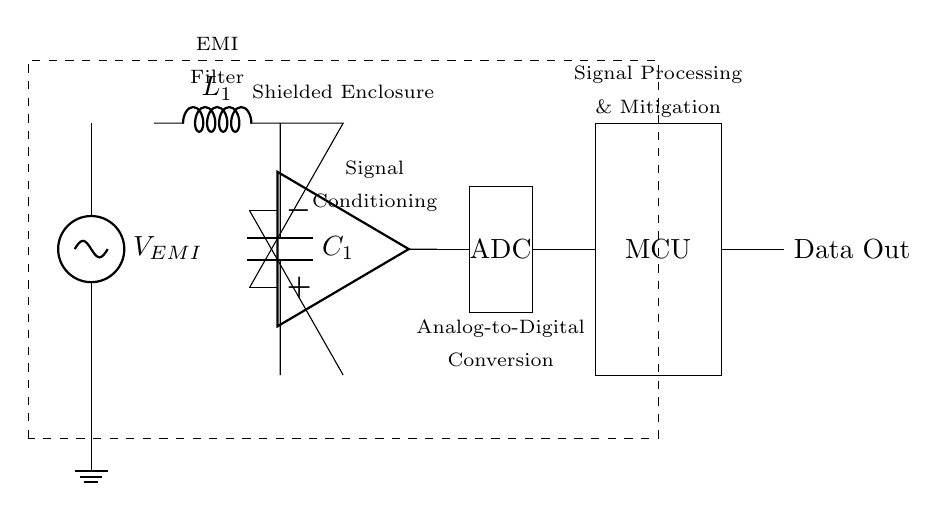What type of component is connected to the voltage source? The voltage source is connected to an inductor as part of the EMI filter, which is depicted just after the voltage source.
Answer: Inductor What does the dashed rectangle represent in this circuit? The dashed rectangle represents a shielded enclosure, which provides physical protection against electromagnetic interference.
Answer: Shielded Enclosure How many components are in the signal conditioning section? The signal conditioning section consists of one op-amp and additional connections, so there is a total of one component (the op-amp) explicitly shown.
Answer: One What is the function of the ADC in this circuit? The ADC converts the analog signals processed by the signal conditioning section into digital signals for the microcontroller to process.
Answer: Analog-to-Digital Conversion What type of circuit is primarily represented in this diagram? This diagram represents an EMI detection and mitigation circuit aimed at protecting sensitive data transmission through filtering and signal processing.
Answer: EMI detection and mitigation circuit How is the output from the ADC connected to the next stage? The output from the ADC connects directly to the microcontroller through a wire, providing the conditioned digital data to be processed.
Answer: Wire connection What is the label for the output from the microcontroller? The output from the microcontroller is labeled as "Data Out," indicating the final data transmission to external systems or components.
Answer: Data Out 